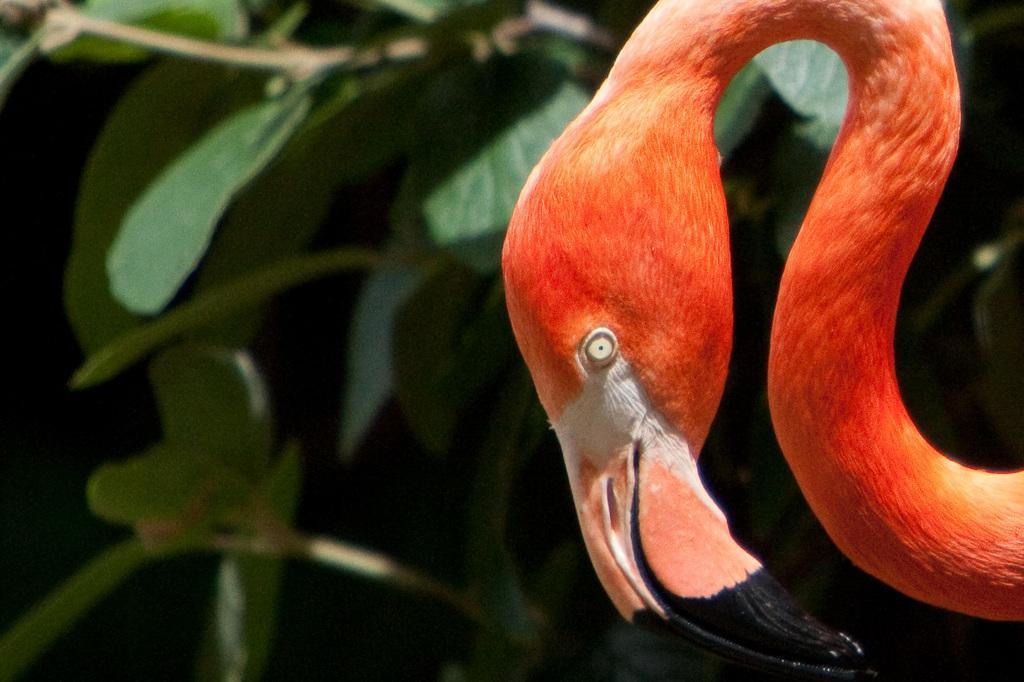Could you give a brief overview of what you see in this image? In this image we can see a animal with orange color with long beak. In the background ,we can see group of plants. 